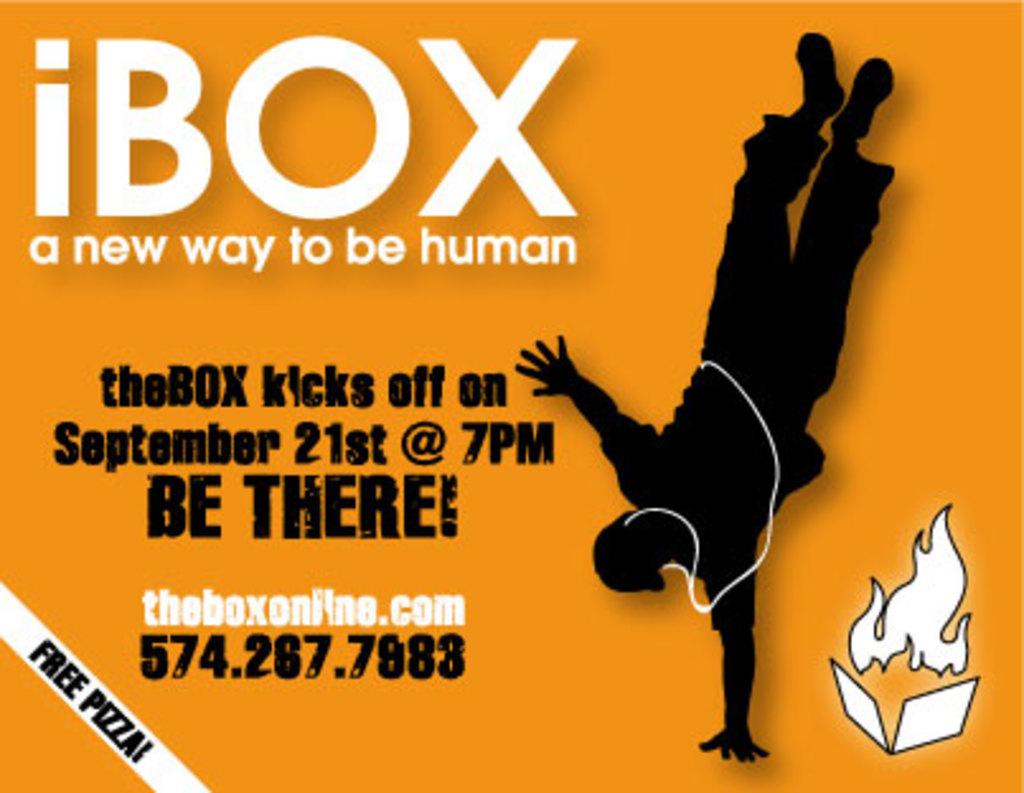What are the giving away for free?
Provide a short and direct response. Pizza. 